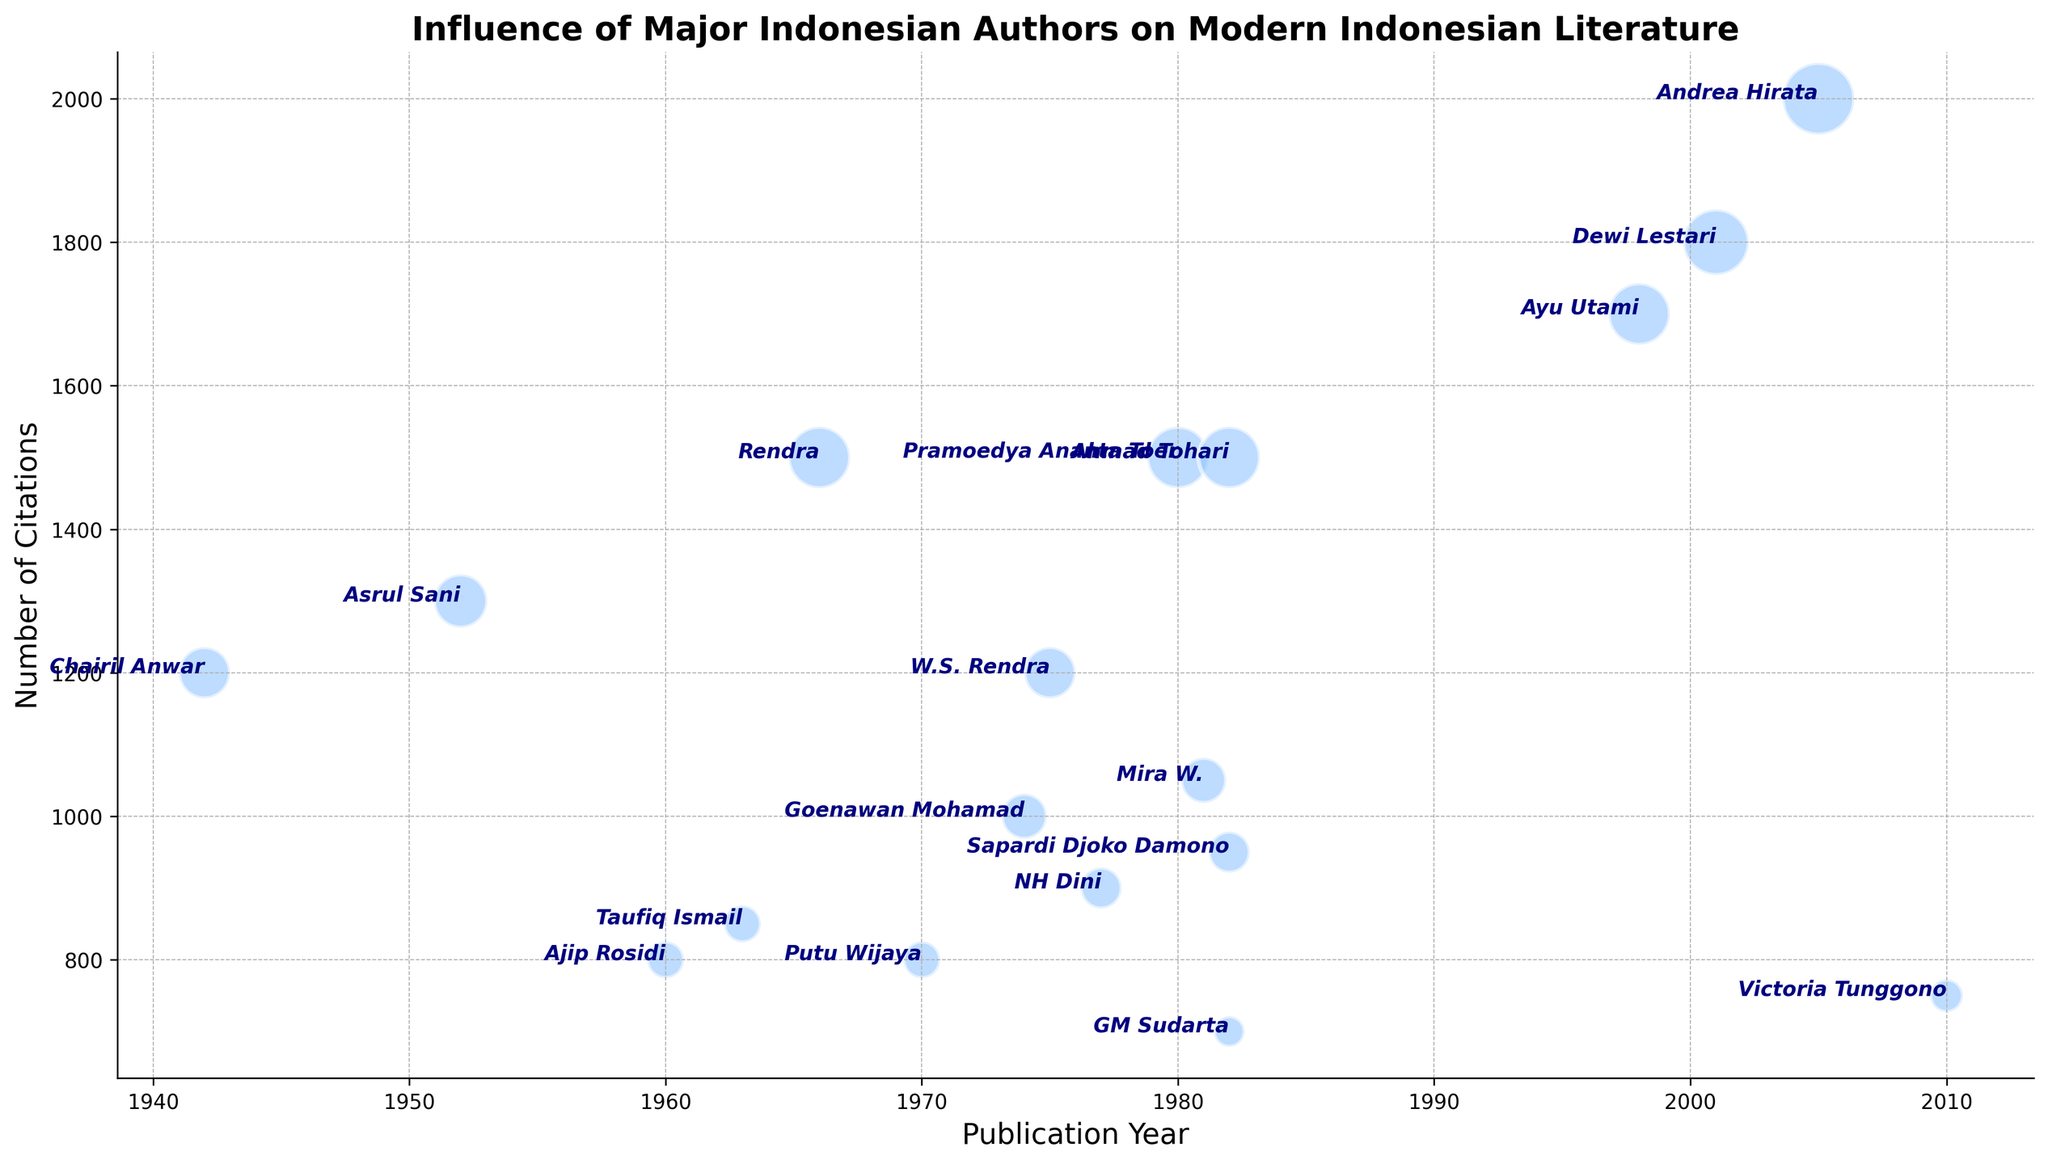Which author has the highest number of citations? To determine which author has the highest number of citations, we look at the data points on the y-axis and identify the one with the largest value. Andrea Hirata has the highest number of citations at 2000.
Answer: Andrea Hirata Which two authors have the same number of citations but different publication years? We look for two authors whose data points on the y-axis fall at the same level but have different x-axis values. Both Pramoedya Ananta Toer (1980) and Rendra (1966) have 1500 citations.
Answer: Pramoedya Ananta Toer and Rendra What is the average publication year of the authors with over 1000 citations? Identify authors with over 1000 citations: Pramoedya Ananta Toer, Chairil Anwar, W.S. Rendra, Mira W., Dewi Lestari, Ayu Utami, Asrul Sani, Andrea Hirata. Their publication years are: 1980, 1942, 1975, 1981, 2001, 1998, 1952, 2005. The average is calculated as follows: (1980 + 1942 + 1975 + 1981 + 2001 + 1998 + 1952 + 2005) / 8 = 15634 / 8 = 1954.25.
Answer: 1954.25 Which authors have a bubble size of 20, and what are their respective publication years? Look at the data entries with a bubble size of 20 and note their publication years. NH Dini (1977) and Sapardi Djoko Damono (1982) both have a bubble size of 20.
Answer: NH Dini (1977) and Sapardi Djoko Damono (1982) Between Dewi Lestari and Ayu Utami, who has more citations? Check the y-axis values corresponding to Dewi Lestari and Ayu Utami. Dewi Lestari has 1800 citations, while Ayu Utami has 1700 citations.
Answer: Dewi Lestari Which author with a publication year in the 1960s has the highest number of citations? Filter the authors by publication years within 1960-1969 and compare their citations. Rendra (1966) has the highest number of citations in this range with 1500.
Answer: Rendra Are there more authors with publication years before 1980 or after 1980, and by how many? Count the number of authors in each group:
- Before 1980: Chairil Anwar, NH Dini, Ajip Rosidi, Rendra, Goenawan Mohamad, W.S. Rendra, Taufiq Ismail, Asrul Sani, Putu Wijaya
- After 1980: Pramoedya Ananta Toer, Sapardi Djoko Damono, Mira W., GM Sudarta, Andrea Hirata, Dewi Lestari, Ayu Utami, Victoria Tunggono
There are 9 authors before 1980 and 8 after 1980, so there is 1 more author before 1980.
Answer: 1 more author before 1980 What is the sum of the citations for authors published in 1982? Identify authors published in 1982: Sapardi Djoko Damono, Ahmad Tohari, GM Sudarta. Their citations are: 950, 1500, and 700 respectively. The total is 950 + 1500 + 700 = 3150.
Answer: 3150 How does the bubble size for Victoria Tunggono compare to the smallest and largest bubbles? Victoria Tunggono has a bubble size of 16. The smallest bubble size is 15 (GM Sudarta), and the largest is 35 (Andrea Hirata). Victoria Tunggono's bubble is larger than the smallest but smaller than the largest.
Answer: Between smallest and largest 